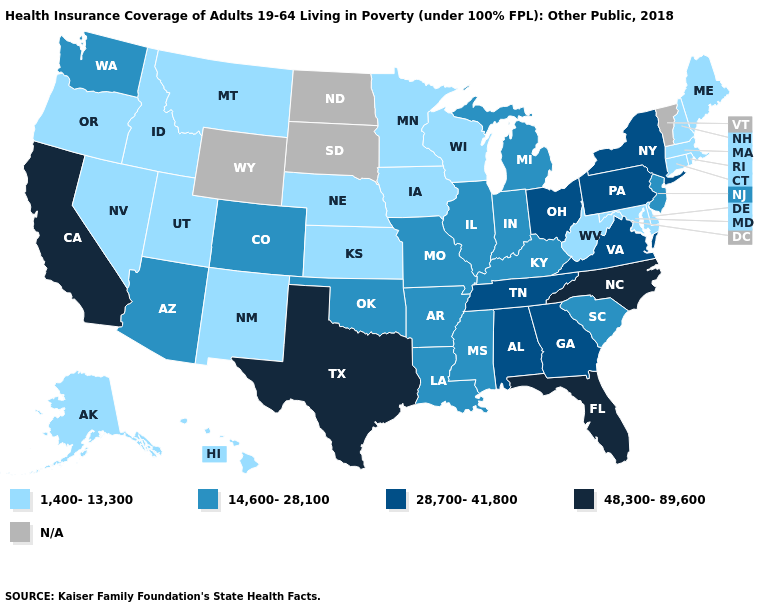What is the value of Washington?
Keep it brief. 14,600-28,100. Which states hav the highest value in the MidWest?
Quick response, please. Ohio. What is the value of Florida?
Write a very short answer. 48,300-89,600. What is the lowest value in the USA?
Write a very short answer. 1,400-13,300. Which states hav the highest value in the West?
Concise answer only. California. What is the lowest value in the USA?
Keep it brief. 1,400-13,300. What is the value of Minnesota?
Give a very brief answer. 1,400-13,300. What is the value of Vermont?
Give a very brief answer. N/A. What is the highest value in the MidWest ?
Quick response, please. 28,700-41,800. What is the value of New Jersey?
Give a very brief answer. 14,600-28,100. Name the states that have a value in the range 48,300-89,600?
Write a very short answer. California, Florida, North Carolina, Texas. How many symbols are there in the legend?
Concise answer only. 5. What is the highest value in the MidWest ?
Keep it brief. 28,700-41,800. Name the states that have a value in the range 14,600-28,100?
Concise answer only. Arizona, Arkansas, Colorado, Illinois, Indiana, Kentucky, Louisiana, Michigan, Mississippi, Missouri, New Jersey, Oklahoma, South Carolina, Washington. Name the states that have a value in the range 14,600-28,100?
Answer briefly. Arizona, Arkansas, Colorado, Illinois, Indiana, Kentucky, Louisiana, Michigan, Mississippi, Missouri, New Jersey, Oklahoma, South Carolina, Washington. 